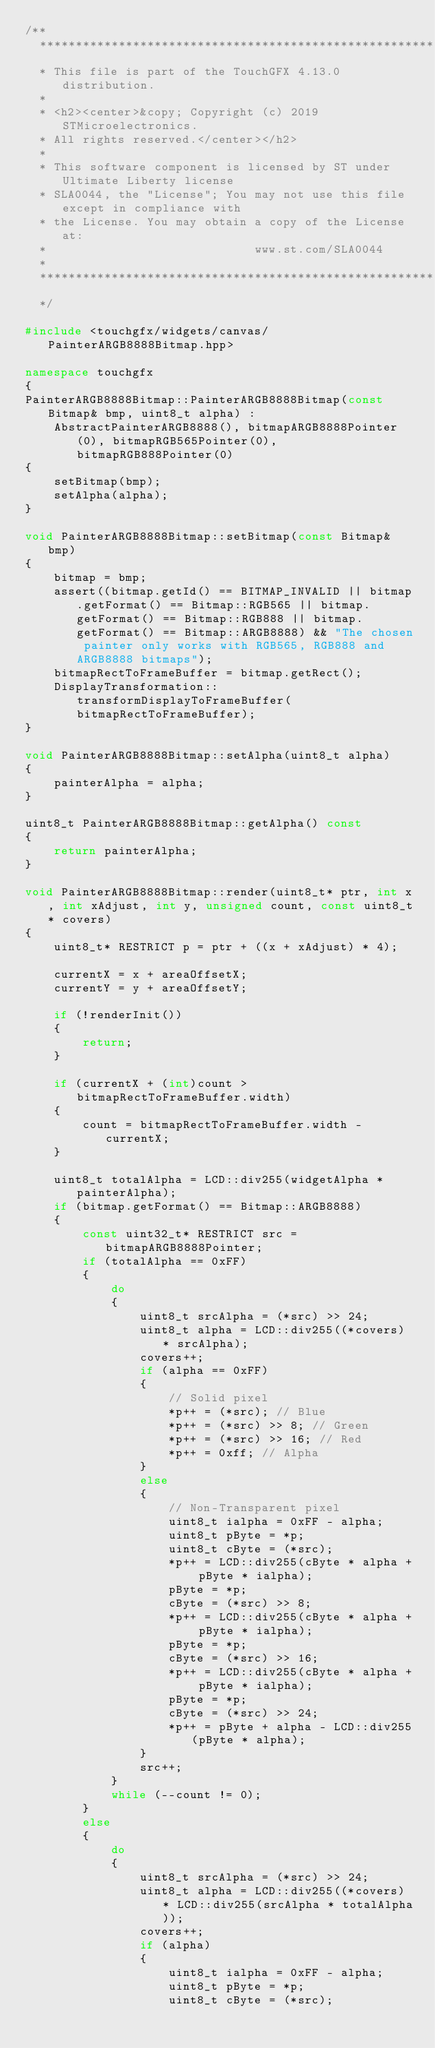Convert code to text. <code><loc_0><loc_0><loc_500><loc_500><_C++_>/**
  ******************************************************************************
  * This file is part of the TouchGFX 4.13.0 distribution.
  *
  * <h2><center>&copy; Copyright (c) 2019 STMicroelectronics.
  * All rights reserved.</center></h2>
  *
  * This software component is licensed by ST under Ultimate Liberty license
  * SLA0044, the "License"; You may not use this file except in compliance with
  * the License. You may obtain a copy of the License at:
  *                             www.st.com/SLA0044
  *
  ******************************************************************************
  */

#include <touchgfx/widgets/canvas/PainterARGB8888Bitmap.hpp>

namespace touchgfx
{
PainterARGB8888Bitmap::PainterARGB8888Bitmap(const Bitmap& bmp, uint8_t alpha) :
    AbstractPainterARGB8888(), bitmapARGB8888Pointer(0), bitmapRGB565Pointer(0), bitmapRGB888Pointer(0)
{
    setBitmap(bmp);
    setAlpha(alpha);
}

void PainterARGB8888Bitmap::setBitmap(const Bitmap& bmp)
{
    bitmap = bmp;
    assert((bitmap.getId() == BITMAP_INVALID || bitmap.getFormat() == Bitmap::RGB565 || bitmap.getFormat() == Bitmap::RGB888 || bitmap.getFormat() == Bitmap::ARGB8888) && "The chosen painter only works with RGB565, RGB888 and ARGB8888 bitmaps");
    bitmapRectToFrameBuffer = bitmap.getRect();
    DisplayTransformation::transformDisplayToFrameBuffer(bitmapRectToFrameBuffer);
}

void PainterARGB8888Bitmap::setAlpha(uint8_t alpha)
{
    painterAlpha = alpha;
}

uint8_t PainterARGB8888Bitmap::getAlpha() const
{
    return painterAlpha;
}

void PainterARGB8888Bitmap::render(uint8_t* ptr, int x, int xAdjust, int y, unsigned count, const uint8_t* covers)
{
    uint8_t* RESTRICT p = ptr + ((x + xAdjust) * 4);

    currentX = x + areaOffsetX;
    currentY = y + areaOffsetY;

    if (!renderInit())
    {
        return;
    }

    if (currentX + (int)count > bitmapRectToFrameBuffer.width)
    {
        count = bitmapRectToFrameBuffer.width - currentX;
    }

    uint8_t totalAlpha = LCD::div255(widgetAlpha * painterAlpha);
    if (bitmap.getFormat() == Bitmap::ARGB8888)
    {
        const uint32_t* RESTRICT src = bitmapARGB8888Pointer;
        if (totalAlpha == 0xFF)
        {
            do
            {
                uint8_t srcAlpha = (*src) >> 24;
                uint8_t alpha = LCD::div255((*covers) * srcAlpha);
                covers++;
                if (alpha == 0xFF)
                {
                    // Solid pixel
                    *p++ = (*src); // Blue
                    *p++ = (*src) >> 8; // Green
                    *p++ = (*src) >> 16; // Red
                    *p++ = 0xff; // Alpha
                }
                else
                {
                    // Non-Transparent pixel
                    uint8_t ialpha = 0xFF - alpha;
                    uint8_t pByte = *p;
                    uint8_t cByte = (*src);
                    *p++ = LCD::div255(cByte * alpha + pByte * ialpha);
                    pByte = *p;
                    cByte = (*src) >> 8;
                    *p++ = LCD::div255(cByte * alpha + pByte * ialpha);
                    pByte = *p;
                    cByte = (*src) >> 16;
                    *p++ = LCD::div255(cByte * alpha + pByte * ialpha);
                    pByte = *p;
                    cByte = (*src) >> 24;
                    *p++ = pByte + alpha - LCD::div255(pByte * alpha);
                }
                src++;
            }
            while (--count != 0);
        }
        else
        {
            do
            {
                uint8_t srcAlpha = (*src) >> 24;
                uint8_t alpha = LCD::div255((*covers) * LCD::div255(srcAlpha * totalAlpha));
                covers++;
                if (alpha)
                {
                    uint8_t ialpha = 0xFF - alpha;
                    uint8_t pByte = *p;
                    uint8_t cByte = (*src);</code> 